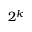Convert formula to latex. <formula><loc_0><loc_0><loc_500><loc_500>2 ^ { k }</formula> 